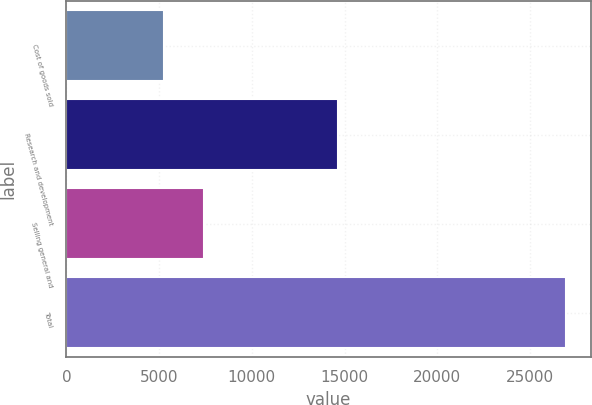Convert chart. <chart><loc_0><loc_0><loc_500><loc_500><bar_chart><fcel>Cost of goods sold<fcel>Research and development<fcel>Selling general and<fcel>Total<nl><fcel>5265<fcel>14650<fcel>7431.8<fcel>26933<nl></chart> 